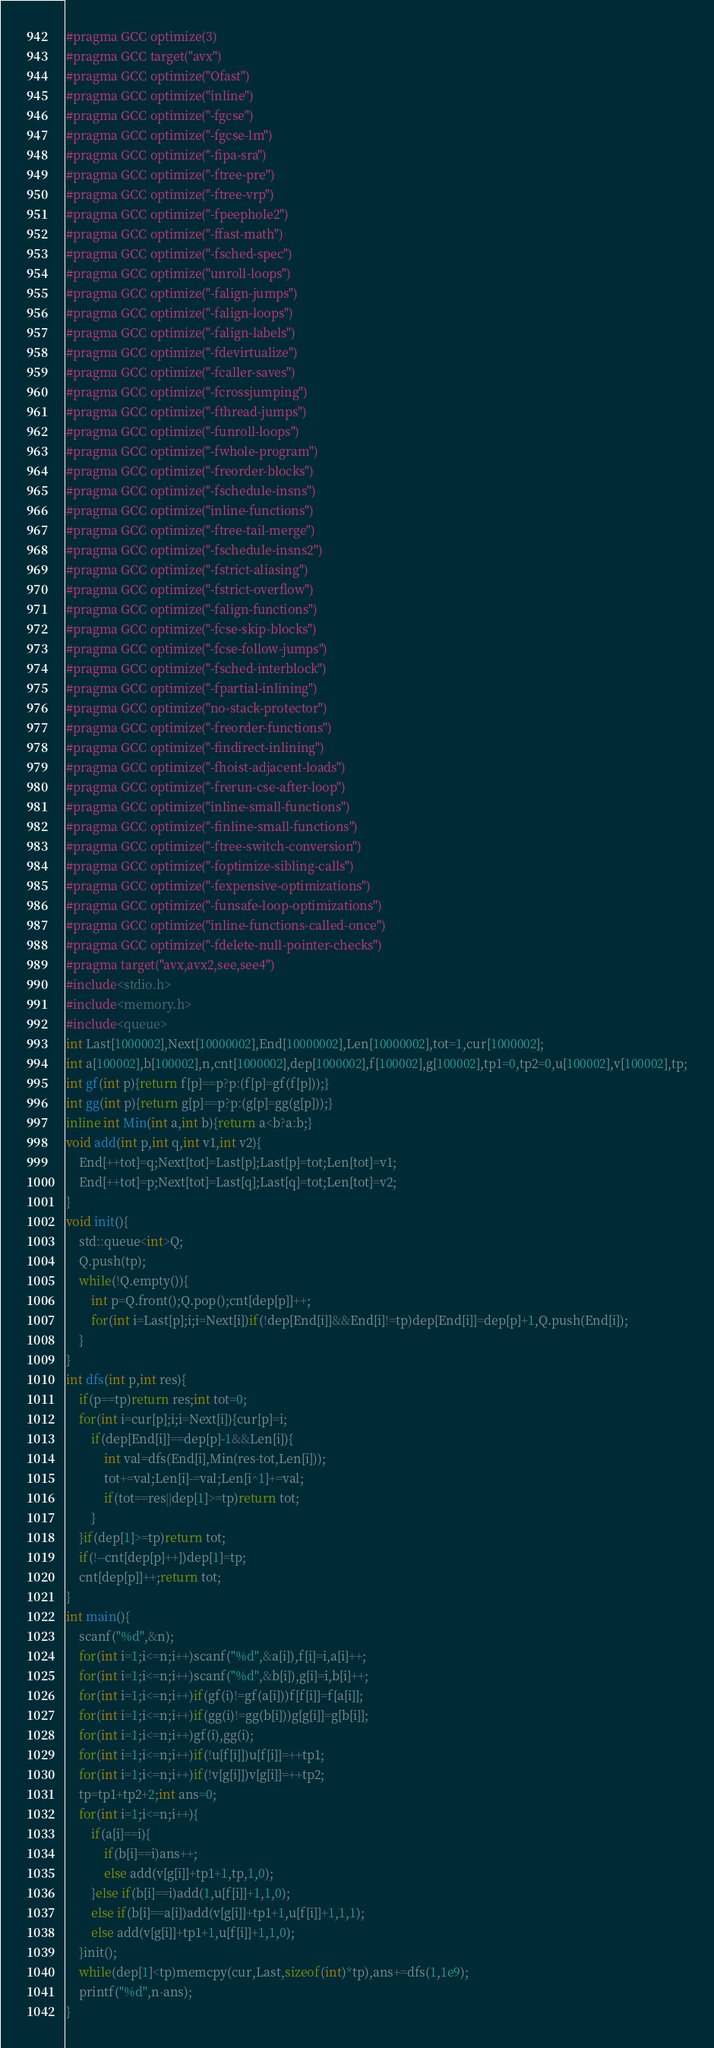Convert code to text. <code><loc_0><loc_0><loc_500><loc_500><_C++_>#pragma GCC optimize(3)
#pragma GCC target("avx")
#pragma GCC optimize("Ofast")
#pragma GCC optimize("inline")
#pragma GCC optimize("-fgcse")
#pragma GCC optimize("-fgcse-lm")
#pragma GCC optimize("-fipa-sra")
#pragma GCC optimize("-ftree-pre")
#pragma GCC optimize("-ftree-vrp")
#pragma GCC optimize("-fpeephole2")
#pragma GCC optimize("-ffast-math")
#pragma GCC optimize("-fsched-spec")
#pragma GCC optimize("unroll-loops")
#pragma GCC optimize("-falign-jumps")
#pragma GCC optimize("-falign-loops")
#pragma GCC optimize("-falign-labels")
#pragma GCC optimize("-fdevirtualize")
#pragma GCC optimize("-fcaller-saves")
#pragma GCC optimize("-fcrossjumping")
#pragma GCC optimize("-fthread-jumps")
#pragma GCC optimize("-funroll-loops")
#pragma GCC optimize("-fwhole-program")
#pragma GCC optimize("-freorder-blocks")
#pragma GCC optimize("-fschedule-insns")
#pragma GCC optimize("inline-functions")
#pragma GCC optimize("-ftree-tail-merge")
#pragma GCC optimize("-fschedule-insns2")
#pragma GCC optimize("-fstrict-aliasing")
#pragma GCC optimize("-fstrict-overflow")
#pragma GCC optimize("-falign-functions")
#pragma GCC optimize("-fcse-skip-blocks")
#pragma GCC optimize("-fcse-follow-jumps")
#pragma GCC optimize("-fsched-interblock")
#pragma GCC optimize("-fpartial-inlining")
#pragma GCC optimize("no-stack-protector")
#pragma GCC optimize("-freorder-functions")
#pragma GCC optimize("-findirect-inlining")
#pragma GCC optimize("-fhoist-adjacent-loads")
#pragma GCC optimize("-frerun-cse-after-loop")
#pragma GCC optimize("inline-small-functions")
#pragma GCC optimize("-finline-small-functions")
#pragma GCC optimize("-ftree-switch-conversion")
#pragma GCC optimize("-foptimize-sibling-calls")
#pragma GCC optimize("-fexpensive-optimizations")
#pragma GCC optimize("-funsafe-loop-optimizations")
#pragma GCC optimize("inline-functions-called-once")
#pragma GCC optimize("-fdelete-null-pointer-checks")
#pragma target("avx,avx2,see,see4")
#include<stdio.h>
#include<memory.h>
#include<queue>
int Last[1000002],Next[10000002],End[10000002],Len[10000002],tot=1,cur[1000002];
int a[100002],b[100002],n,cnt[1000002],dep[1000002],f[100002],g[100002],tp1=0,tp2=0,u[100002],v[100002],tp;
int gf(int p){return f[p]==p?p:(f[p]=gf(f[p]));}
int gg(int p){return g[p]==p?p:(g[p]=gg(g[p]));}
inline int Min(int a,int b){return a<b?a:b;}
void add(int p,int q,int v1,int v2){
	End[++tot]=q;Next[tot]=Last[p];Last[p]=tot;Len[tot]=v1;
	End[++tot]=p;Next[tot]=Last[q];Last[q]=tot;Len[tot]=v2;
}
void init(){
	std::queue<int>Q;
	Q.push(tp);
	while(!Q.empty()){
		int p=Q.front();Q.pop();cnt[dep[p]]++;
		for(int i=Last[p];i;i=Next[i])if(!dep[End[i]]&&End[i]!=tp)dep[End[i]]=dep[p]+1,Q.push(End[i]);
	}
}
int dfs(int p,int res){
	if(p==tp)return res;int tot=0;
	for(int i=cur[p];i;i=Next[i]){cur[p]=i;
		if(dep[End[i]]==dep[p]-1&&Len[i]){
			int val=dfs(End[i],Min(res-tot,Len[i]));
			tot+=val;Len[i]-=val;Len[i^1]+=val;
			if(tot==res||dep[1]>=tp)return tot;
		}
	}if(dep[1]>=tp)return tot;
	if(!--cnt[dep[p]++])dep[1]=tp;
	cnt[dep[p]]++;return tot;
}
int main(){
	scanf("%d",&n);
	for(int i=1;i<=n;i++)scanf("%d",&a[i]),f[i]=i,a[i]++;
	for(int i=1;i<=n;i++)scanf("%d",&b[i]),g[i]=i,b[i]++;
	for(int i=1;i<=n;i++)if(gf(i)!=gf(a[i]))f[f[i]]=f[a[i]];
	for(int i=1;i<=n;i++)if(gg(i)!=gg(b[i]))g[g[i]]=g[b[i]];
	for(int i=1;i<=n;i++)gf(i),gg(i);
	for(int i=1;i<=n;i++)if(!u[f[i]])u[f[i]]=++tp1;
	for(int i=1;i<=n;i++)if(!v[g[i]])v[g[i]]=++tp2;
	tp=tp1+tp2+2;int ans=0;
	for(int i=1;i<=n;i++){
		if(a[i]==i){
			if(b[i]==i)ans++;
			else add(v[g[i]]+tp1+1,tp,1,0);
		}else if(b[i]==i)add(1,u[f[i]]+1,1,0);
		else if(b[i]==a[i])add(v[g[i]]+tp1+1,u[f[i]]+1,1,1);
		else add(v[g[i]]+tp1+1,u[f[i]]+1,1,0);
	}init();
	while(dep[1]<tp)memcpy(cur,Last,sizeof(int)*tp),ans+=dfs(1,1e9);
	printf("%d",n-ans);
}</code> 